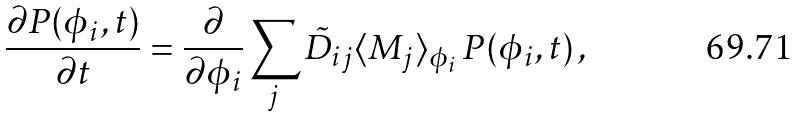Convert formula to latex. <formula><loc_0><loc_0><loc_500><loc_500>\frac { \partial P ( \phi _ { i } , t ) } { \partial t } = \frac { \partial } { \partial \phi _ { i } } \sum _ { j } \tilde { D } _ { i j } \langle M _ { j } \rangle _ { \phi _ { i } } \, P ( \phi _ { i } , t ) \, ,</formula> 